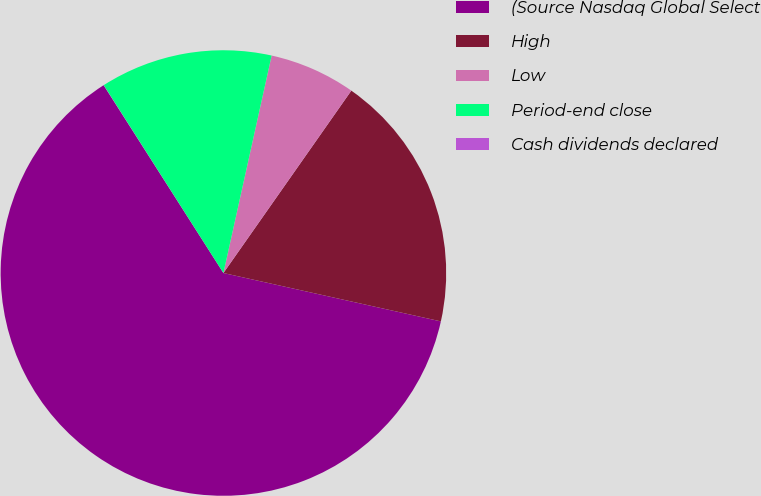<chart> <loc_0><loc_0><loc_500><loc_500><pie_chart><fcel>(Source Nasdaq Global Select<fcel>High<fcel>Low<fcel>Period-end close<fcel>Cash dividends declared<nl><fcel>62.48%<fcel>18.75%<fcel>6.26%<fcel>12.5%<fcel>0.01%<nl></chart> 